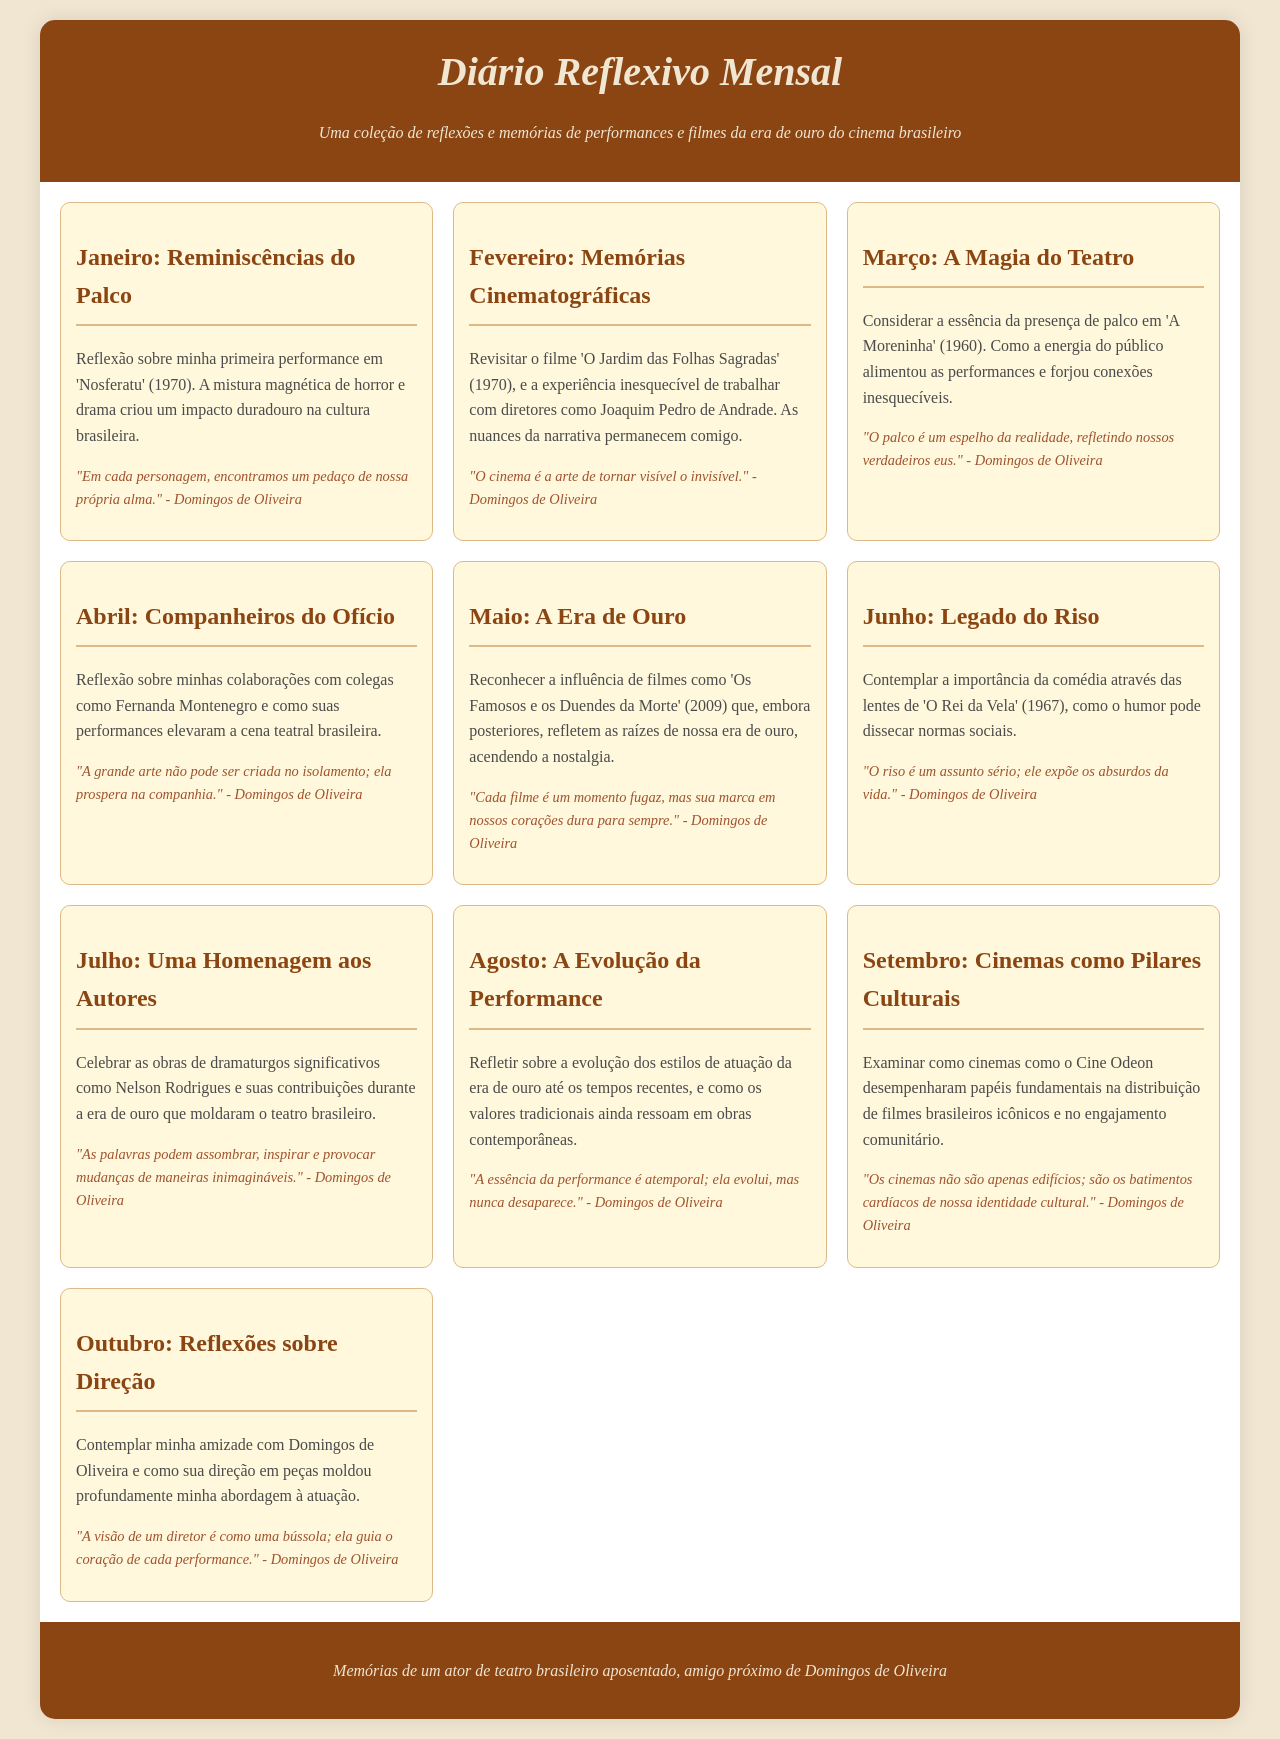what is the title of the document? The title is prominently displayed at the top of the document, indicating the theme.
Answer: Diário Reflexivo Mensal which month focuses on "Reminiscências do Palco"? The titles of each month's section are clearly listed under each header.
Answer: Janeiro who is quoted in the reflections? The quotes are attributed consistently to a single individual throughout the document.
Answer: Domingos de Oliveira what is the theme of the reflection for Junho? Each month outlines a specific theme or focus, which can be identified from the text.
Answer: Legado do Riso how many months are covered in the document? The document includes a section for each month, totaling all the months listed.
Answer: Dez which film is mentioned for the month of Fevereiro? The specific film discussed is noted in the content for that month.
Answer: O Jardim das Folhas Sagradas what style is used for the main text? The document describes the visual style used throughout, particularly for the body text.
Answer: Georgia what is the color of the header background? The color specifications for various sections are detailed in the CSS styles.
Answer: #8b4513 in which month is "A Moreninha" highlighted? The reflection for a particular month centers around this specific work.
Answer: Março 